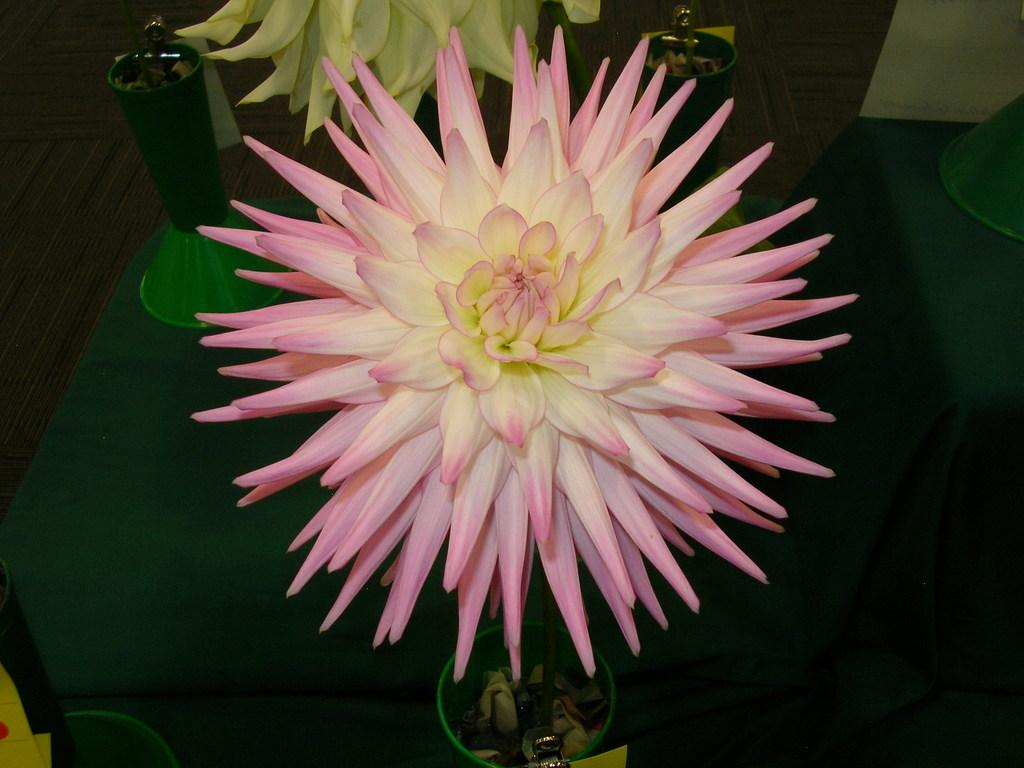What is the main subject of the image? The main subject of the image is a flower. Where is the flower located in the image? The flower is on a green-colored stage. What type of scarf is draped over the flower in the image? There is no scarf present in the image; it features a flower on a green-colored stage. What type of dress is the flower wearing in the image? Flowers do not wear dresses, as they are inanimate objects. 